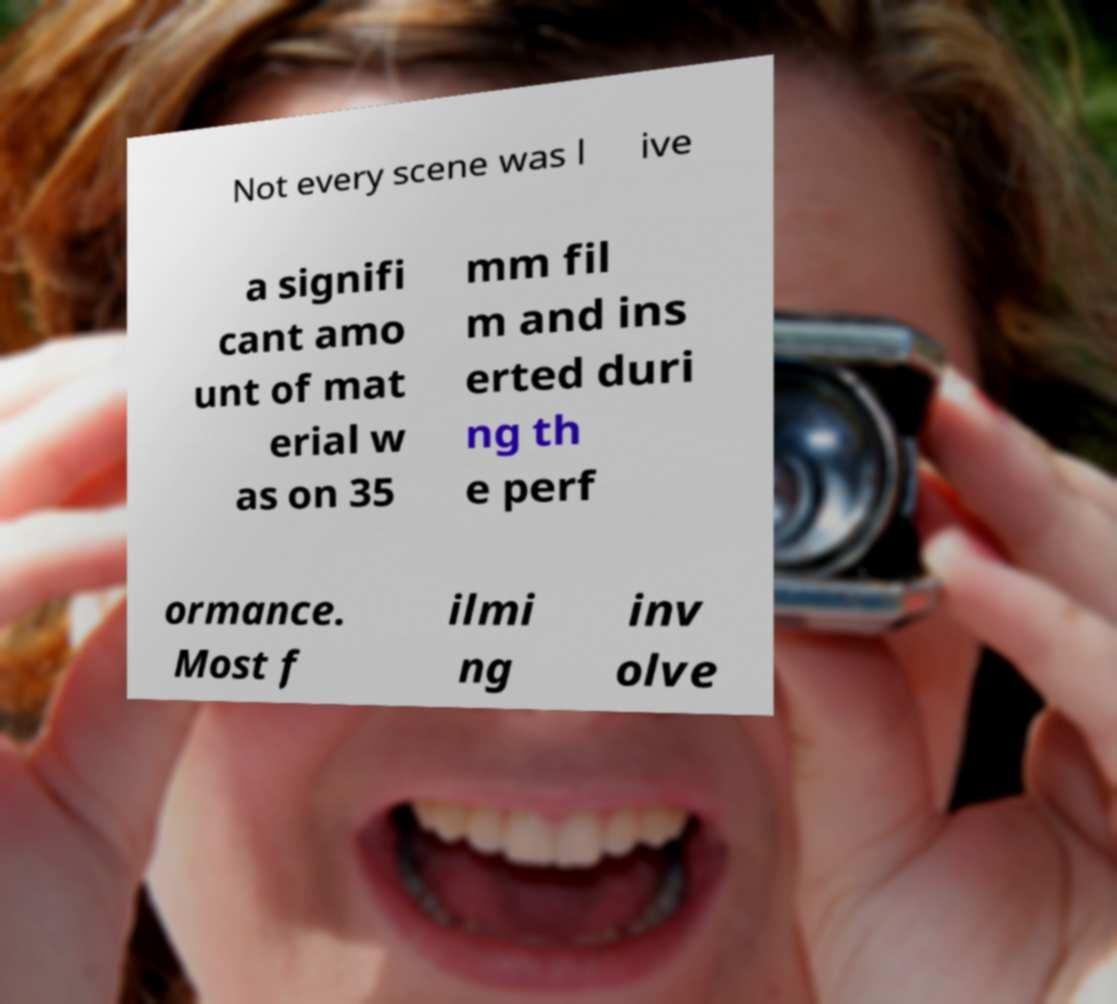Can you accurately transcribe the text from the provided image for me? Not every scene was l ive a signifi cant amo unt of mat erial w as on 35 mm fil m and ins erted duri ng th e perf ormance. Most f ilmi ng inv olve 